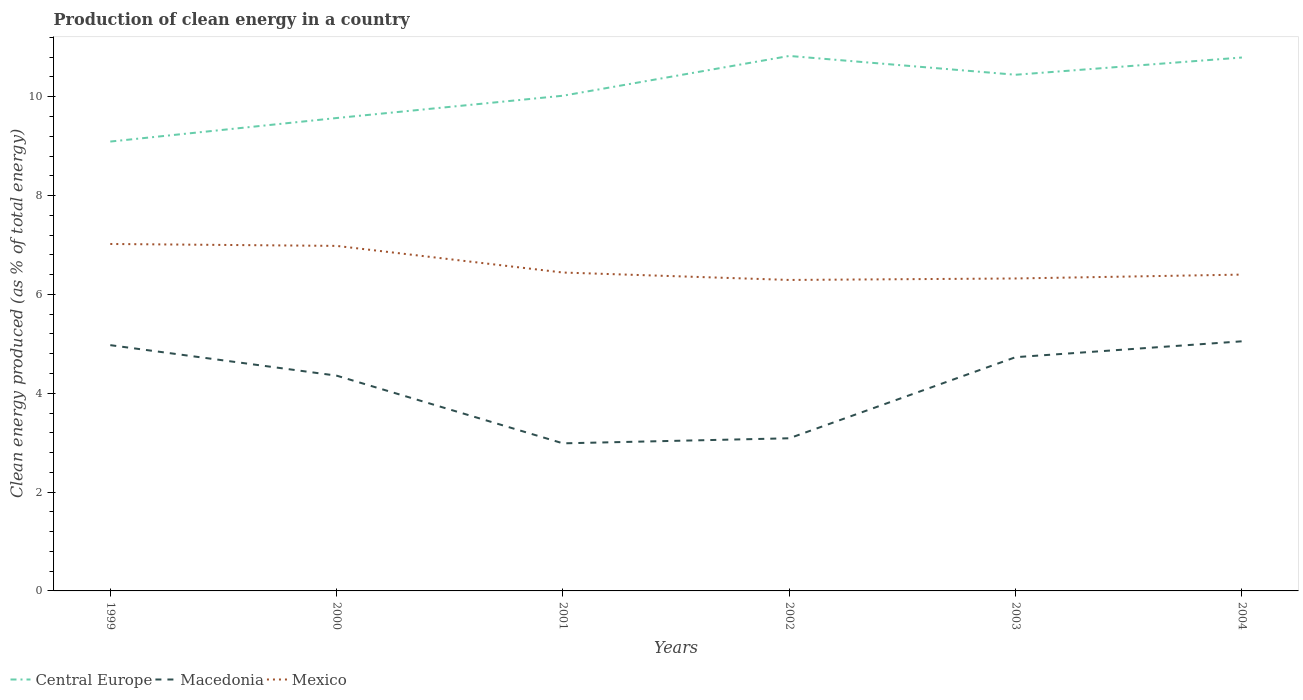Is the number of lines equal to the number of legend labels?
Your answer should be compact. Yes. Across all years, what is the maximum percentage of clean energy produced in Macedonia?
Give a very brief answer. 2.99. What is the total percentage of clean energy produced in Macedonia in the graph?
Provide a succinct answer. 0.24. What is the difference between the highest and the second highest percentage of clean energy produced in Mexico?
Keep it short and to the point. 0.73. What is the difference between the highest and the lowest percentage of clean energy produced in Central Europe?
Keep it short and to the point. 3. Is the percentage of clean energy produced in Central Europe strictly greater than the percentage of clean energy produced in Mexico over the years?
Offer a terse response. No. How many lines are there?
Your response must be concise. 3. How many years are there in the graph?
Your response must be concise. 6. What is the difference between two consecutive major ticks on the Y-axis?
Provide a short and direct response. 2. Are the values on the major ticks of Y-axis written in scientific E-notation?
Your response must be concise. No. Where does the legend appear in the graph?
Keep it short and to the point. Bottom left. How are the legend labels stacked?
Offer a very short reply. Horizontal. What is the title of the graph?
Provide a short and direct response. Production of clean energy in a country. Does "Nepal" appear as one of the legend labels in the graph?
Your answer should be very brief. No. What is the label or title of the Y-axis?
Offer a very short reply. Clean energy produced (as % of total energy). What is the Clean energy produced (as % of total energy) in Central Europe in 1999?
Offer a terse response. 9.09. What is the Clean energy produced (as % of total energy) of Macedonia in 1999?
Keep it short and to the point. 4.97. What is the Clean energy produced (as % of total energy) of Mexico in 1999?
Provide a succinct answer. 7.02. What is the Clean energy produced (as % of total energy) of Central Europe in 2000?
Offer a terse response. 9.57. What is the Clean energy produced (as % of total energy) of Macedonia in 2000?
Keep it short and to the point. 4.36. What is the Clean energy produced (as % of total energy) in Mexico in 2000?
Offer a very short reply. 6.98. What is the Clean energy produced (as % of total energy) of Central Europe in 2001?
Ensure brevity in your answer.  10.02. What is the Clean energy produced (as % of total energy) in Macedonia in 2001?
Your response must be concise. 2.99. What is the Clean energy produced (as % of total energy) of Mexico in 2001?
Offer a terse response. 6.44. What is the Clean energy produced (as % of total energy) of Central Europe in 2002?
Provide a succinct answer. 10.83. What is the Clean energy produced (as % of total energy) in Macedonia in 2002?
Your response must be concise. 3.09. What is the Clean energy produced (as % of total energy) in Mexico in 2002?
Your response must be concise. 6.29. What is the Clean energy produced (as % of total energy) of Central Europe in 2003?
Give a very brief answer. 10.45. What is the Clean energy produced (as % of total energy) in Macedonia in 2003?
Give a very brief answer. 4.73. What is the Clean energy produced (as % of total energy) of Mexico in 2003?
Your response must be concise. 6.32. What is the Clean energy produced (as % of total energy) in Central Europe in 2004?
Ensure brevity in your answer.  10.79. What is the Clean energy produced (as % of total energy) in Macedonia in 2004?
Keep it short and to the point. 5.05. What is the Clean energy produced (as % of total energy) in Mexico in 2004?
Provide a succinct answer. 6.4. Across all years, what is the maximum Clean energy produced (as % of total energy) of Central Europe?
Keep it short and to the point. 10.83. Across all years, what is the maximum Clean energy produced (as % of total energy) of Macedonia?
Your response must be concise. 5.05. Across all years, what is the maximum Clean energy produced (as % of total energy) in Mexico?
Keep it short and to the point. 7.02. Across all years, what is the minimum Clean energy produced (as % of total energy) of Central Europe?
Offer a very short reply. 9.09. Across all years, what is the minimum Clean energy produced (as % of total energy) of Macedonia?
Keep it short and to the point. 2.99. Across all years, what is the minimum Clean energy produced (as % of total energy) in Mexico?
Provide a succinct answer. 6.29. What is the total Clean energy produced (as % of total energy) in Central Europe in the graph?
Your answer should be very brief. 60.75. What is the total Clean energy produced (as % of total energy) in Macedonia in the graph?
Your answer should be very brief. 25.19. What is the total Clean energy produced (as % of total energy) of Mexico in the graph?
Give a very brief answer. 39.46. What is the difference between the Clean energy produced (as % of total energy) in Central Europe in 1999 and that in 2000?
Offer a terse response. -0.48. What is the difference between the Clean energy produced (as % of total energy) in Macedonia in 1999 and that in 2000?
Provide a succinct answer. 0.62. What is the difference between the Clean energy produced (as % of total energy) in Mexico in 1999 and that in 2000?
Give a very brief answer. 0.04. What is the difference between the Clean energy produced (as % of total energy) in Central Europe in 1999 and that in 2001?
Offer a terse response. -0.93. What is the difference between the Clean energy produced (as % of total energy) in Macedonia in 1999 and that in 2001?
Your answer should be compact. 1.99. What is the difference between the Clean energy produced (as % of total energy) in Mexico in 1999 and that in 2001?
Provide a short and direct response. 0.58. What is the difference between the Clean energy produced (as % of total energy) in Central Europe in 1999 and that in 2002?
Offer a terse response. -1.73. What is the difference between the Clean energy produced (as % of total energy) in Macedonia in 1999 and that in 2002?
Your response must be concise. 1.88. What is the difference between the Clean energy produced (as % of total energy) in Mexico in 1999 and that in 2002?
Your answer should be compact. 0.73. What is the difference between the Clean energy produced (as % of total energy) in Central Europe in 1999 and that in 2003?
Make the answer very short. -1.35. What is the difference between the Clean energy produced (as % of total energy) of Macedonia in 1999 and that in 2003?
Provide a short and direct response. 0.24. What is the difference between the Clean energy produced (as % of total energy) of Mexico in 1999 and that in 2003?
Offer a terse response. 0.7. What is the difference between the Clean energy produced (as % of total energy) of Central Europe in 1999 and that in 2004?
Keep it short and to the point. -1.7. What is the difference between the Clean energy produced (as % of total energy) of Macedonia in 1999 and that in 2004?
Offer a terse response. -0.08. What is the difference between the Clean energy produced (as % of total energy) in Mexico in 1999 and that in 2004?
Your response must be concise. 0.62. What is the difference between the Clean energy produced (as % of total energy) of Central Europe in 2000 and that in 2001?
Your answer should be very brief. -0.45. What is the difference between the Clean energy produced (as % of total energy) in Macedonia in 2000 and that in 2001?
Provide a succinct answer. 1.37. What is the difference between the Clean energy produced (as % of total energy) of Mexico in 2000 and that in 2001?
Your answer should be compact. 0.54. What is the difference between the Clean energy produced (as % of total energy) in Central Europe in 2000 and that in 2002?
Give a very brief answer. -1.26. What is the difference between the Clean energy produced (as % of total energy) of Macedonia in 2000 and that in 2002?
Your answer should be very brief. 1.27. What is the difference between the Clean energy produced (as % of total energy) in Mexico in 2000 and that in 2002?
Provide a succinct answer. 0.69. What is the difference between the Clean energy produced (as % of total energy) of Central Europe in 2000 and that in 2003?
Offer a very short reply. -0.88. What is the difference between the Clean energy produced (as % of total energy) in Macedonia in 2000 and that in 2003?
Make the answer very short. -0.37. What is the difference between the Clean energy produced (as % of total energy) of Mexico in 2000 and that in 2003?
Your response must be concise. 0.66. What is the difference between the Clean energy produced (as % of total energy) of Central Europe in 2000 and that in 2004?
Provide a short and direct response. -1.22. What is the difference between the Clean energy produced (as % of total energy) of Macedonia in 2000 and that in 2004?
Your answer should be compact. -0.69. What is the difference between the Clean energy produced (as % of total energy) in Mexico in 2000 and that in 2004?
Offer a very short reply. 0.58. What is the difference between the Clean energy produced (as % of total energy) in Central Europe in 2001 and that in 2002?
Your answer should be very brief. -0.8. What is the difference between the Clean energy produced (as % of total energy) of Macedonia in 2001 and that in 2002?
Your answer should be compact. -0.1. What is the difference between the Clean energy produced (as % of total energy) of Mexico in 2001 and that in 2002?
Your answer should be very brief. 0.15. What is the difference between the Clean energy produced (as % of total energy) of Central Europe in 2001 and that in 2003?
Make the answer very short. -0.42. What is the difference between the Clean energy produced (as % of total energy) of Macedonia in 2001 and that in 2003?
Offer a very short reply. -1.74. What is the difference between the Clean energy produced (as % of total energy) of Mexico in 2001 and that in 2003?
Keep it short and to the point. 0.12. What is the difference between the Clean energy produced (as % of total energy) in Central Europe in 2001 and that in 2004?
Keep it short and to the point. -0.77. What is the difference between the Clean energy produced (as % of total energy) in Macedonia in 2001 and that in 2004?
Ensure brevity in your answer.  -2.06. What is the difference between the Clean energy produced (as % of total energy) of Mexico in 2001 and that in 2004?
Make the answer very short. 0.04. What is the difference between the Clean energy produced (as % of total energy) of Central Europe in 2002 and that in 2003?
Provide a short and direct response. 0.38. What is the difference between the Clean energy produced (as % of total energy) in Macedonia in 2002 and that in 2003?
Your response must be concise. -1.64. What is the difference between the Clean energy produced (as % of total energy) of Mexico in 2002 and that in 2003?
Offer a terse response. -0.03. What is the difference between the Clean energy produced (as % of total energy) of Central Europe in 2002 and that in 2004?
Provide a succinct answer. 0.03. What is the difference between the Clean energy produced (as % of total energy) in Macedonia in 2002 and that in 2004?
Keep it short and to the point. -1.96. What is the difference between the Clean energy produced (as % of total energy) in Mexico in 2002 and that in 2004?
Keep it short and to the point. -0.11. What is the difference between the Clean energy produced (as % of total energy) in Central Europe in 2003 and that in 2004?
Your answer should be compact. -0.35. What is the difference between the Clean energy produced (as % of total energy) in Macedonia in 2003 and that in 2004?
Your answer should be compact. -0.32. What is the difference between the Clean energy produced (as % of total energy) of Mexico in 2003 and that in 2004?
Offer a very short reply. -0.08. What is the difference between the Clean energy produced (as % of total energy) of Central Europe in 1999 and the Clean energy produced (as % of total energy) of Macedonia in 2000?
Offer a terse response. 4.74. What is the difference between the Clean energy produced (as % of total energy) in Central Europe in 1999 and the Clean energy produced (as % of total energy) in Mexico in 2000?
Your answer should be compact. 2.11. What is the difference between the Clean energy produced (as % of total energy) of Macedonia in 1999 and the Clean energy produced (as % of total energy) of Mexico in 2000?
Your answer should be very brief. -2.01. What is the difference between the Clean energy produced (as % of total energy) in Central Europe in 1999 and the Clean energy produced (as % of total energy) in Macedonia in 2001?
Offer a very short reply. 6.11. What is the difference between the Clean energy produced (as % of total energy) in Central Europe in 1999 and the Clean energy produced (as % of total energy) in Mexico in 2001?
Ensure brevity in your answer.  2.65. What is the difference between the Clean energy produced (as % of total energy) in Macedonia in 1999 and the Clean energy produced (as % of total energy) in Mexico in 2001?
Provide a succinct answer. -1.47. What is the difference between the Clean energy produced (as % of total energy) of Central Europe in 1999 and the Clean energy produced (as % of total energy) of Macedonia in 2002?
Offer a very short reply. 6. What is the difference between the Clean energy produced (as % of total energy) of Central Europe in 1999 and the Clean energy produced (as % of total energy) of Mexico in 2002?
Provide a short and direct response. 2.8. What is the difference between the Clean energy produced (as % of total energy) of Macedonia in 1999 and the Clean energy produced (as % of total energy) of Mexico in 2002?
Your answer should be compact. -1.32. What is the difference between the Clean energy produced (as % of total energy) in Central Europe in 1999 and the Clean energy produced (as % of total energy) in Macedonia in 2003?
Keep it short and to the point. 4.36. What is the difference between the Clean energy produced (as % of total energy) of Central Europe in 1999 and the Clean energy produced (as % of total energy) of Mexico in 2003?
Provide a short and direct response. 2.77. What is the difference between the Clean energy produced (as % of total energy) in Macedonia in 1999 and the Clean energy produced (as % of total energy) in Mexico in 2003?
Offer a very short reply. -1.35. What is the difference between the Clean energy produced (as % of total energy) in Central Europe in 1999 and the Clean energy produced (as % of total energy) in Macedonia in 2004?
Offer a terse response. 4.04. What is the difference between the Clean energy produced (as % of total energy) of Central Europe in 1999 and the Clean energy produced (as % of total energy) of Mexico in 2004?
Ensure brevity in your answer.  2.69. What is the difference between the Clean energy produced (as % of total energy) of Macedonia in 1999 and the Clean energy produced (as % of total energy) of Mexico in 2004?
Your answer should be compact. -1.43. What is the difference between the Clean energy produced (as % of total energy) of Central Europe in 2000 and the Clean energy produced (as % of total energy) of Macedonia in 2001?
Keep it short and to the point. 6.58. What is the difference between the Clean energy produced (as % of total energy) of Central Europe in 2000 and the Clean energy produced (as % of total energy) of Mexico in 2001?
Provide a short and direct response. 3.13. What is the difference between the Clean energy produced (as % of total energy) of Macedonia in 2000 and the Clean energy produced (as % of total energy) of Mexico in 2001?
Ensure brevity in your answer.  -2.09. What is the difference between the Clean energy produced (as % of total energy) of Central Europe in 2000 and the Clean energy produced (as % of total energy) of Macedonia in 2002?
Offer a terse response. 6.48. What is the difference between the Clean energy produced (as % of total energy) of Central Europe in 2000 and the Clean energy produced (as % of total energy) of Mexico in 2002?
Offer a terse response. 3.28. What is the difference between the Clean energy produced (as % of total energy) in Macedonia in 2000 and the Clean energy produced (as % of total energy) in Mexico in 2002?
Offer a terse response. -1.94. What is the difference between the Clean energy produced (as % of total energy) in Central Europe in 2000 and the Clean energy produced (as % of total energy) in Macedonia in 2003?
Make the answer very short. 4.84. What is the difference between the Clean energy produced (as % of total energy) of Central Europe in 2000 and the Clean energy produced (as % of total energy) of Mexico in 2003?
Your response must be concise. 3.25. What is the difference between the Clean energy produced (as % of total energy) of Macedonia in 2000 and the Clean energy produced (as % of total energy) of Mexico in 2003?
Make the answer very short. -1.97. What is the difference between the Clean energy produced (as % of total energy) in Central Europe in 2000 and the Clean energy produced (as % of total energy) in Macedonia in 2004?
Your answer should be very brief. 4.52. What is the difference between the Clean energy produced (as % of total energy) of Central Europe in 2000 and the Clean energy produced (as % of total energy) of Mexico in 2004?
Your answer should be very brief. 3.17. What is the difference between the Clean energy produced (as % of total energy) in Macedonia in 2000 and the Clean energy produced (as % of total energy) in Mexico in 2004?
Offer a terse response. -2.04. What is the difference between the Clean energy produced (as % of total energy) of Central Europe in 2001 and the Clean energy produced (as % of total energy) of Macedonia in 2002?
Provide a succinct answer. 6.93. What is the difference between the Clean energy produced (as % of total energy) of Central Europe in 2001 and the Clean energy produced (as % of total energy) of Mexico in 2002?
Keep it short and to the point. 3.73. What is the difference between the Clean energy produced (as % of total energy) in Macedonia in 2001 and the Clean energy produced (as % of total energy) in Mexico in 2002?
Your response must be concise. -3.31. What is the difference between the Clean energy produced (as % of total energy) of Central Europe in 2001 and the Clean energy produced (as % of total energy) of Macedonia in 2003?
Offer a terse response. 5.29. What is the difference between the Clean energy produced (as % of total energy) in Central Europe in 2001 and the Clean energy produced (as % of total energy) in Mexico in 2003?
Make the answer very short. 3.7. What is the difference between the Clean energy produced (as % of total energy) in Macedonia in 2001 and the Clean energy produced (as % of total energy) in Mexico in 2003?
Offer a very short reply. -3.34. What is the difference between the Clean energy produced (as % of total energy) of Central Europe in 2001 and the Clean energy produced (as % of total energy) of Macedonia in 2004?
Your answer should be very brief. 4.97. What is the difference between the Clean energy produced (as % of total energy) of Central Europe in 2001 and the Clean energy produced (as % of total energy) of Mexico in 2004?
Offer a very short reply. 3.62. What is the difference between the Clean energy produced (as % of total energy) in Macedonia in 2001 and the Clean energy produced (as % of total energy) in Mexico in 2004?
Ensure brevity in your answer.  -3.41. What is the difference between the Clean energy produced (as % of total energy) in Central Europe in 2002 and the Clean energy produced (as % of total energy) in Macedonia in 2003?
Your answer should be very brief. 6.1. What is the difference between the Clean energy produced (as % of total energy) in Central Europe in 2002 and the Clean energy produced (as % of total energy) in Mexico in 2003?
Your response must be concise. 4.5. What is the difference between the Clean energy produced (as % of total energy) of Macedonia in 2002 and the Clean energy produced (as % of total energy) of Mexico in 2003?
Your answer should be very brief. -3.23. What is the difference between the Clean energy produced (as % of total energy) in Central Europe in 2002 and the Clean energy produced (as % of total energy) in Macedonia in 2004?
Offer a terse response. 5.77. What is the difference between the Clean energy produced (as % of total energy) in Central Europe in 2002 and the Clean energy produced (as % of total energy) in Mexico in 2004?
Offer a very short reply. 4.42. What is the difference between the Clean energy produced (as % of total energy) in Macedonia in 2002 and the Clean energy produced (as % of total energy) in Mexico in 2004?
Your answer should be very brief. -3.31. What is the difference between the Clean energy produced (as % of total energy) in Central Europe in 2003 and the Clean energy produced (as % of total energy) in Macedonia in 2004?
Ensure brevity in your answer.  5.39. What is the difference between the Clean energy produced (as % of total energy) of Central Europe in 2003 and the Clean energy produced (as % of total energy) of Mexico in 2004?
Ensure brevity in your answer.  4.04. What is the difference between the Clean energy produced (as % of total energy) in Macedonia in 2003 and the Clean energy produced (as % of total energy) in Mexico in 2004?
Keep it short and to the point. -1.67. What is the average Clean energy produced (as % of total energy) of Central Europe per year?
Your response must be concise. 10.12. What is the average Clean energy produced (as % of total energy) of Macedonia per year?
Make the answer very short. 4.2. What is the average Clean energy produced (as % of total energy) in Mexico per year?
Offer a very short reply. 6.58. In the year 1999, what is the difference between the Clean energy produced (as % of total energy) of Central Europe and Clean energy produced (as % of total energy) of Macedonia?
Your answer should be compact. 4.12. In the year 1999, what is the difference between the Clean energy produced (as % of total energy) of Central Europe and Clean energy produced (as % of total energy) of Mexico?
Make the answer very short. 2.07. In the year 1999, what is the difference between the Clean energy produced (as % of total energy) of Macedonia and Clean energy produced (as % of total energy) of Mexico?
Provide a short and direct response. -2.05. In the year 2000, what is the difference between the Clean energy produced (as % of total energy) of Central Europe and Clean energy produced (as % of total energy) of Macedonia?
Your response must be concise. 5.21. In the year 2000, what is the difference between the Clean energy produced (as % of total energy) of Central Europe and Clean energy produced (as % of total energy) of Mexico?
Provide a short and direct response. 2.59. In the year 2000, what is the difference between the Clean energy produced (as % of total energy) in Macedonia and Clean energy produced (as % of total energy) in Mexico?
Ensure brevity in your answer.  -2.63. In the year 2001, what is the difference between the Clean energy produced (as % of total energy) of Central Europe and Clean energy produced (as % of total energy) of Macedonia?
Give a very brief answer. 7.03. In the year 2001, what is the difference between the Clean energy produced (as % of total energy) of Central Europe and Clean energy produced (as % of total energy) of Mexico?
Give a very brief answer. 3.58. In the year 2001, what is the difference between the Clean energy produced (as % of total energy) in Macedonia and Clean energy produced (as % of total energy) in Mexico?
Offer a very short reply. -3.46. In the year 2002, what is the difference between the Clean energy produced (as % of total energy) of Central Europe and Clean energy produced (as % of total energy) of Macedonia?
Offer a terse response. 7.74. In the year 2002, what is the difference between the Clean energy produced (as % of total energy) of Central Europe and Clean energy produced (as % of total energy) of Mexico?
Your answer should be very brief. 4.53. In the year 2002, what is the difference between the Clean energy produced (as % of total energy) in Macedonia and Clean energy produced (as % of total energy) in Mexico?
Ensure brevity in your answer.  -3.2. In the year 2003, what is the difference between the Clean energy produced (as % of total energy) in Central Europe and Clean energy produced (as % of total energy) in Macedonia?
Offer a terse response. 5.71. In the year 2003, what is the difference between the Clean energy produced (as % of total energy) in Central Europe and Clean energy produced (as % of total energy) in Mexico?
Your answer should be very brief. 4.12. In the year 2003, what is the difference between the Clean energy produced (as % of total energy) of Macedonia and Clean energy produced (as % of total energy) of Mexico?
Your response must be concise. -1.59. In the year 2004, what is the difference between the Clean energy produced (as % of total energy) of Central Europe and Clean energy produced (as % of total energy) of Macedonia?
Give a very brief answer. 5.74. In the year 2004, what is the difference between the Clean energy produced (as % of total energy) in Central Europe and Clean energy produced (as % of total energy) in Mexico?
Ensure brevity in your answer.  4.39. In the year 2004, what is the difference between the Clean energy produced (as % of total energy) of Macedonia and Clean energy produced (as % of total energy) of Mexico?
Keep it short and to the point. -1.35. What is the ratio of the Clean energy produced (as % of total energy) of Central Europe in 1999 to that in 2000?
Keep it short and to the point. 0.95. What is the ratio of the Clean energy produced (as % of total energy) in Macedonia in 1999 to that in 2000?
Provide a succinct answer. 1.14. What is the ratio of the Clean energy produced (as % of total energy) in Mexico in 1999 to that in 2000?
Make the answer very short. 1.01. What is the ratio of the Clean energy produced (as % of total energy) in Central Europe in 1999 to that in 2001?
Make the answer very short. 0.91. What is the ratio of the Clean energy produced (as % of total energy) of Macedonia in 1999 to that in 2001?
Ensure brevity in your answer.  1.67. What is the ratio of the Clean energy produced (as % of total energy) of Mexico in 1999 to that in 2001?
Provide a short and direct response. 1.09. What is the ratio of the Clean energy produced (as % of total energy) of Central Europe in 1999 to that in 2002?
Provide a short and direct response. 0.84. What is the ratio of the Clean energy produced (as % of total energy) in Macedonia in 1999 to that in 2002?
Provide a succinct answer. 1.61. What is the ratio of the Clean energy produced (as % of total energy) of Mexico in 1999 to that in 2002?
Make the answer very short. 1.12. What is the ratio of the Clean energy produced (as % of total energy) in Central Europe in 1999 to that in 2003?
Offer a very short reply. 0.87. What is the ratio of the Clean energy produced (as % of total energy) in Macedonia in 1999 to that in 2003?
Ensure brevity in your answer.  1.05. What is the ratio of the Clean energy produced (as % of total energy) of Mexico in 1999 to that in 2003?
Make the answer very short. 1.11. What is the ratio of the Clean energy produced (as % of total energy) in Central Europe in 1999 to that in 2004?
Provide a succinct answer. 0.84. What is the ratio of the Clean energy produced (as % of total energy) in Macedonia in 1999 to that in 2004?
Offer a very short reply. 0.98. What is the ratio of the Clean energy produced (as % of total energy) of Mexico in 1999 to that in 2004?
Give a very brief answer. 1.1. What is the ratio of the Clean energy produced (as % of total energy) of Central Europe in 2000 to that in 2001?
Your answer should be compact. 0.95. What is the ratio of the Clean energy produced (as % of total energy) in Macedonia in 2000 to that in 2001?
Provide a short and direct response. 1.46. What is the ratio of the Clean energy produced (as % of total energy) of Mexico in 2000 to that in 2001?
Provide a succinct answer. 1.08. What is the ratio of the Clean energy produced (as % of total energy) in Central Europe in 2000 to that in 2002?
Offer a very short reply. 0.88. What is the ratio of the Clean energy produced (as % of total energy) in Macedonia in 2000 to that in 2002?
Ensure brevity in your answer.  1.41. What is the ratio of the Clean energy produced (as % of total energy) of Mexico in 2000 to that in 2002?
Keep it short and to the point. 1.11. What is the ratio of the Clean energy produced (as % of total energy) of Central Europe in 2000 to that in 2003?
Give a very brief answer. 0.92. What is the ratio of the Clean energy produced (as % of total energy) of Macedonia in 2000 to that in 2003?
Make the answer very short. 0.92. What is the ratio of the Clean energy produced (as % of total energy) of Mexico in 2000 to that in 2003?
Keep it short and to the point. 1.1. What is the ratio of the Clean energy produced (as % of total energy) of Central Europe in 2000 to that in 2004?
Provide a short and direct response. 0.89. What is the ratio of the Clean energy produced (as % of total energy) in Macedonia in 2000 to that in 2004?
Offer a terse response. 0.86. What is the ratio of the Clean energy produced (as % of total energy) of Mexico in 2000 to that in 2004?
Make the answer very short. 1.09. What is the ratio of the Clean energy produced (as % of total energy) in Central Europe in 2001 to that in 2002?
Offer a terse response. 0.93. What is the ratio of the Clean energy produced (as % of total energy) of Macedonia in 2001 to that in 2002?
Make the answer very short. 0.97. What is the ratio of the Clean energy produced (as % of total energy) in Mexico in 2001 to that in 2002?
Keep it short and to the point. 1.02. What is the ratio of the Clean energy produced (as % of total energy) in Central Europe in 2001 to that in 2003?
Your answer should be compact. 0.96. What is the ratio of the Clean energy produced (as % of total energy) of Macedonia in 2001 to that in 2003?
Offer a terse response. 0.63. What is the ratio of the Clean energy produced (as % of total energy) in Mexico in 2001 to that in 2003?
Provide a short and direct response. 1.02. What is the ratio of the Clean energy produced (as % of total energy) of Central Europe in 2001 to that in 2004?
Provide a short and direct response. 0.93. What is the ratio of the Clean energy produced (as % of total energy) in Macedonia in 2001 to that in 2004?
Offer a terse response. 0.59. What is the ratio of the Clean energy produced (as % of total energy) in Mexico in 2001 to that in 2004?
Keep it short and to the point. 1.01. What is the ratio of the Clean energy produced (as % of total energy) of Central Europe in 2002 to that in 2003?
Ensure brevity in your answer.  1.04. What is the ratio of the Clean energy produced (as % of total energy) of Macedonia in 2002 to that in 2003?
Offer a terse response. 0.65. What is the ratio of the Clean energy produced (as % of total energy) in Central Europe in 2002 to that in 2004?
Make the answer very short. 1. What is the ratio of the Clean energy produced (as % of total energy) of Macedonia in 2002 to that in 2004?
Offer a terse response. 0.61. What is the ratio of the Clean energy produced (as % of total energy) in Mexico in 2002 to that in 2004?
Give a very brief answer. 0.98. What is the ratio of the Clean energy produced (as % of total energy) in Macedonia in 2003 to that in 2004?
Your answer should be very brief. 0.94. What is the ratio of the Clean energy produced (as % of total energy) in Mexico in 2003 to that in 2004?
Provide a short and direct response. 0.99. What is the difference between the highest and the second highest Clean energy produced (as % of total energy) in Central Europe?
Offer a terse response. 0.03. What is the difference between the highest and the second highest Clean energy produced (as % of total energy) in Macedonia?
Provide a succinct answer. 0.08. What is the difference between the highest and the second highest Clean energy produced (as % of total energy) of Mexico?
Provide a short and direct response. 0.04. What is the difference between the highest and the lowest Clean energy produced (as % of total energy) of Central Europe?
Your response must be concise. 1.73. What is the difference between the highest and the lowest Clean energy produced (as % of total energy) in Macedonia?
Your answer should be compact. 2.06. What is the difference between the highest and the lowest Clean energy produced (as % of total energy) in Mexico?
Provide a succinct answer. 0.73. 